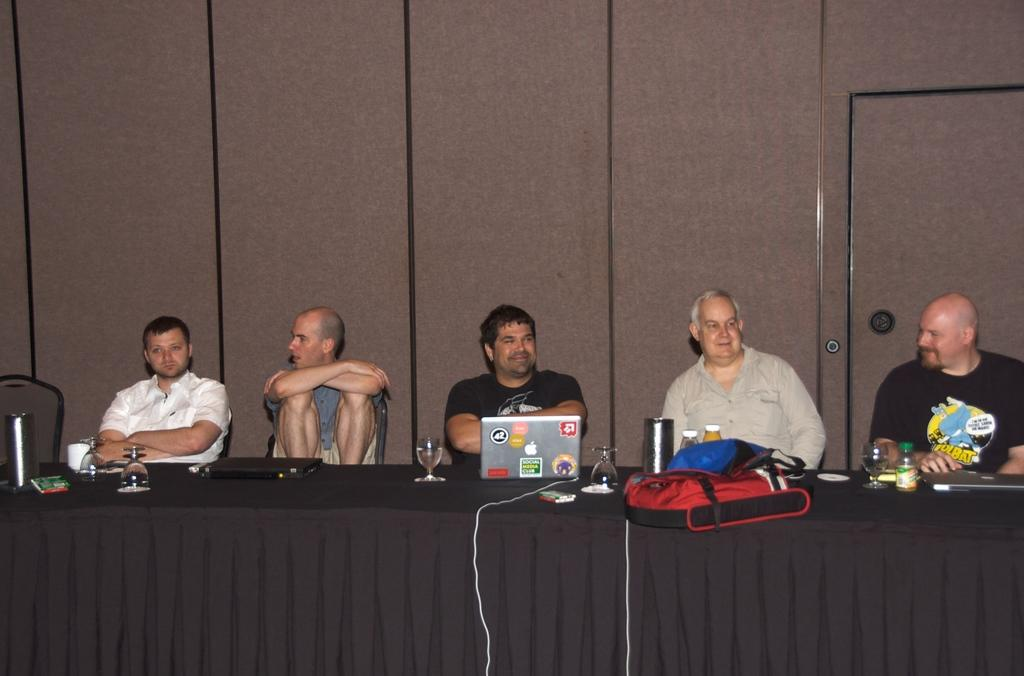How many people are sitting in the chair in the image? There are five people sitting in a chair in the image. What is on the table in the image? There is a laptop, a bottle, and a bag on the table in the image. What can be seen in the background of the image? There is a cupboard visible in the background. What type of kick is being performed by the farmer in the image? There is no farmer or kick present in the image; it features five people sitting in a chair and various objects on a table. What type of camera is being used to capture the image? The question about the camera is irrelevant, as the conversation is focused on describing the contents of the image, not the device used to capture it. 